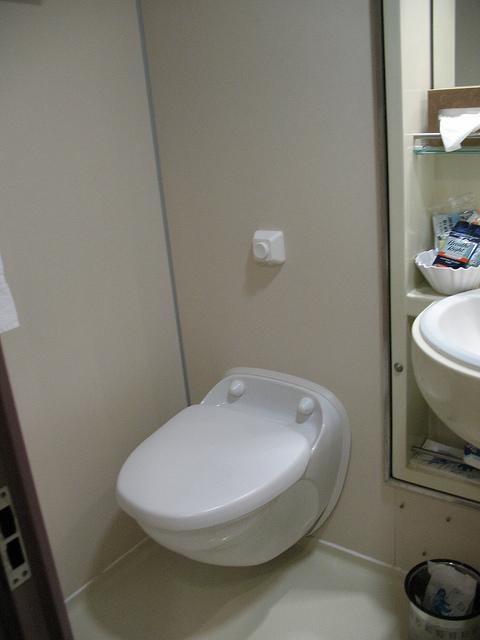Are there any tissues?
Be succinct. Yes. Is there a trash can?
Quick response, please. Yes. Is the toilet attached to the floor?
Answer briefly. No. Is the lid up or down?
Short answer required. Down. 